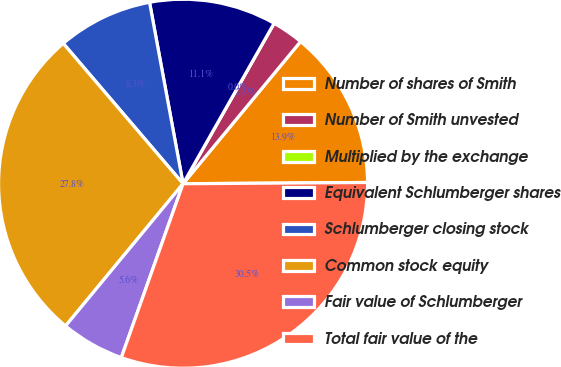<chart> <loc_0><loc_0><loc_500><loc_500><pie_chart><fcel>Number of shares of Smith<fcel>Number of Smith unvested<fcel>Multiplied by the exchange<fcel>Equivalent Schlumberger shares<fcel>Schlumberger closing stock<fcel>Common stock equity<fcel>Fair value of Schlumberger<fcel>Total fair value of the<nl><fcel>13.9%<fcel>2.78%<fcel>0.0%<fcel>11.12%<fcel>8.34%<fcel>27.76%<fcel>5.56%<fcel>30.54%<nl></chart> 